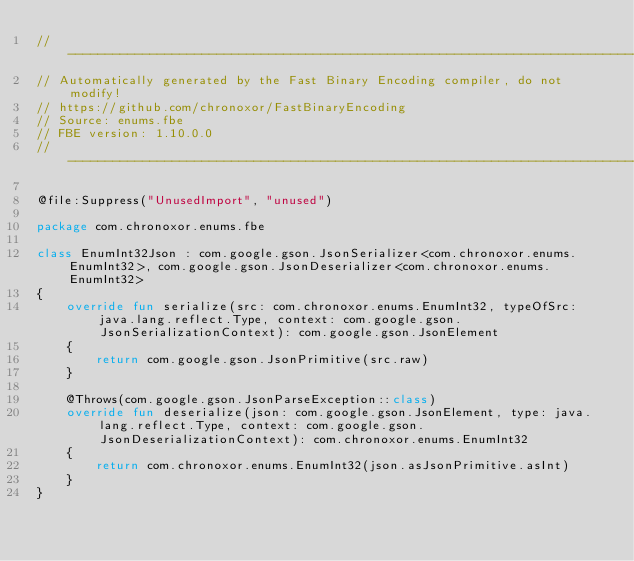Convert code to text. <code><loc_0><loc_0><loc_500><loc_500><_Kotlin_>//------------------------------------------------------------------------------
// Automatically generated by the Fast Binary Encoding compiler, do not modify!
// https://github.com/chronoxor/FastBinaryEncoding
// Source: enums.fbe
// FBE version: 1.10.0.0
//------------------------------------------------------------------------------

@file:Suppress("UnusedImport", "unused")

package com.chronoxor.enums.fbe

class EnumInt32Json : com.google.gson.JsonSerializer<com.chronoxor.enums.EnumInt32>, com.google.gson.JsonDeserializer<com.chronoxor.enums.EnumInt32>
{
    override fun serialize(src: com.chronoxor.enums.EnumInt32, typeOfSrc: java.lang.reflect.Type, context: com.google.gson.JsonSerializationContext): com.google.gson.JsonElement
    {
        return com.google.gson.JsonPrimitive(src.raw)
    }

    @Throws(com.google.gson.JsonParseException::class)
    override fun deserialize(json: com.google.gson.JsonElement, type: java.lang.reflect.Type, context: com.google.gson.JsonDeserializationContext): com.chronoxor.enums.EnumInt32
    {
        return com.chronoxor.enums.EnumInt32(json.asJsonPrimitive.asInt)
    }
}
</code> 